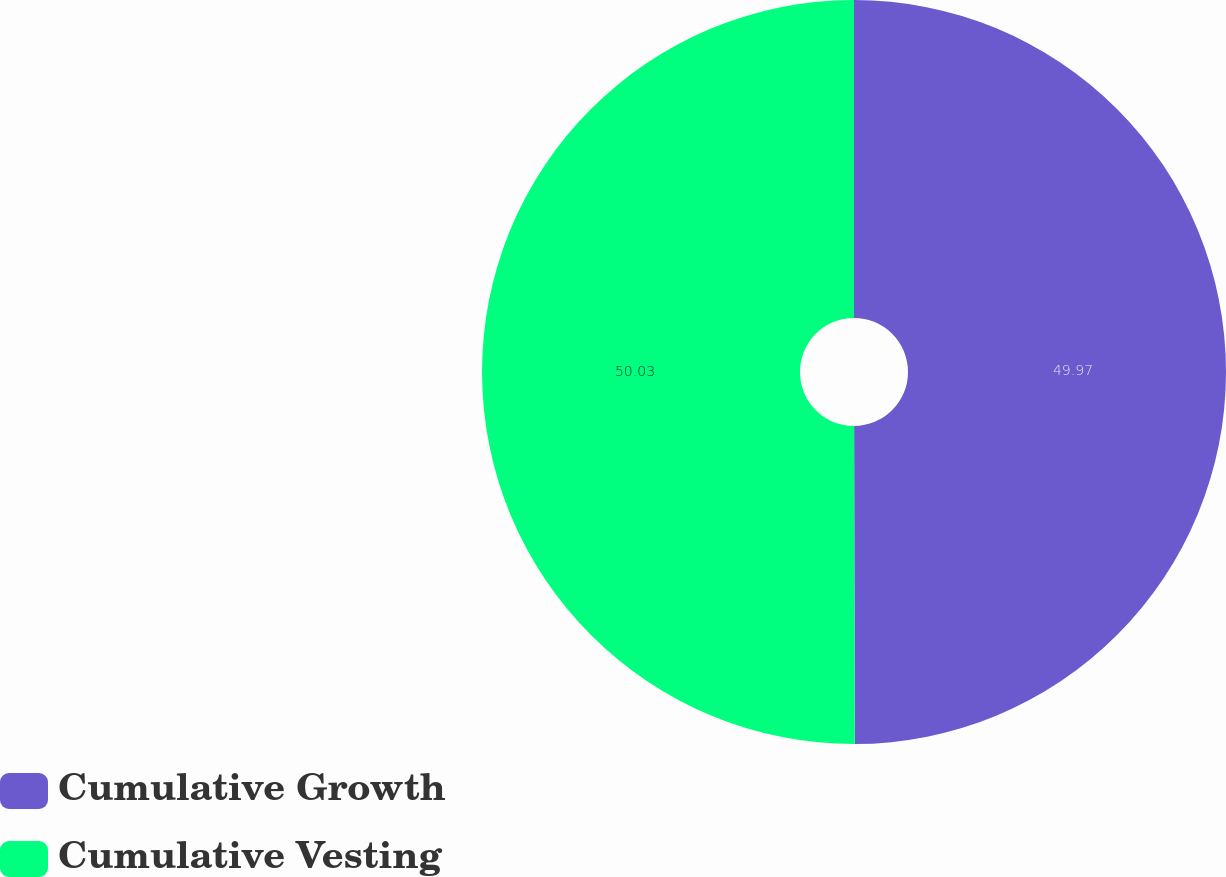<chart> <loc_0><loc_0><loc_500><loc_500><pie_chart><fcel>Cumulative Growth<fcel>Cumulative Vesting<nl><fcel>49.97%<fcel>50.03%<nl></chart> 